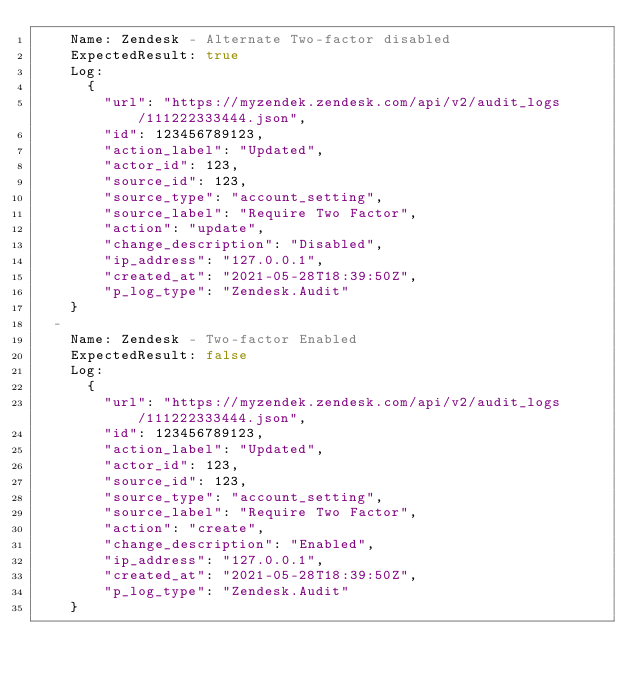Convert code to text. <code><loc_0><loc_0><loc_500><loc_500><_YAML_>    Name: Zendesk - Alternate Two-factor disabled
    ExpectedResult: true
    Log:
      {
        "url": "https://myzendek.zendesk.com/api/v2/audit_logs/111222333444.json",
        "id": 123456789123,
        "action_label": "Updated",
        "actor_id": 123,
        "source_id": 123,
        "source_type": "account_setting",
        "source_label": "Require Two Factor",
        "action": "update",
        "change_description": "Disabled",
        "ip_address": "127.0.0.1",
        "created_at": "2021-05-28T18:39:50Z",
        "p_log_type": "Zendesk.Audit"
    }
  -
    Name: Zendesk - Two-factor Enabled
    ExpectedResult: false
    Log:
      {
        "url": "https://myzendek.zendesk.com/api/v2/audit_logs/111222333444.json",
        "id": 123456789123,
        "action_label": "Updated",
        "actor_id": 123,
        "source_id": 123,
        "source_type": "account_setting",
        "source_label": "Require Two Factor",
        "action": "create",
        "change_description": "Enabled",
        "ip_address": "127.0.0.1",
        "created_at": "2021-05-28T18:39:50Z",
        "p_log_type": "Zendesk.Audit"
    }
</code> 